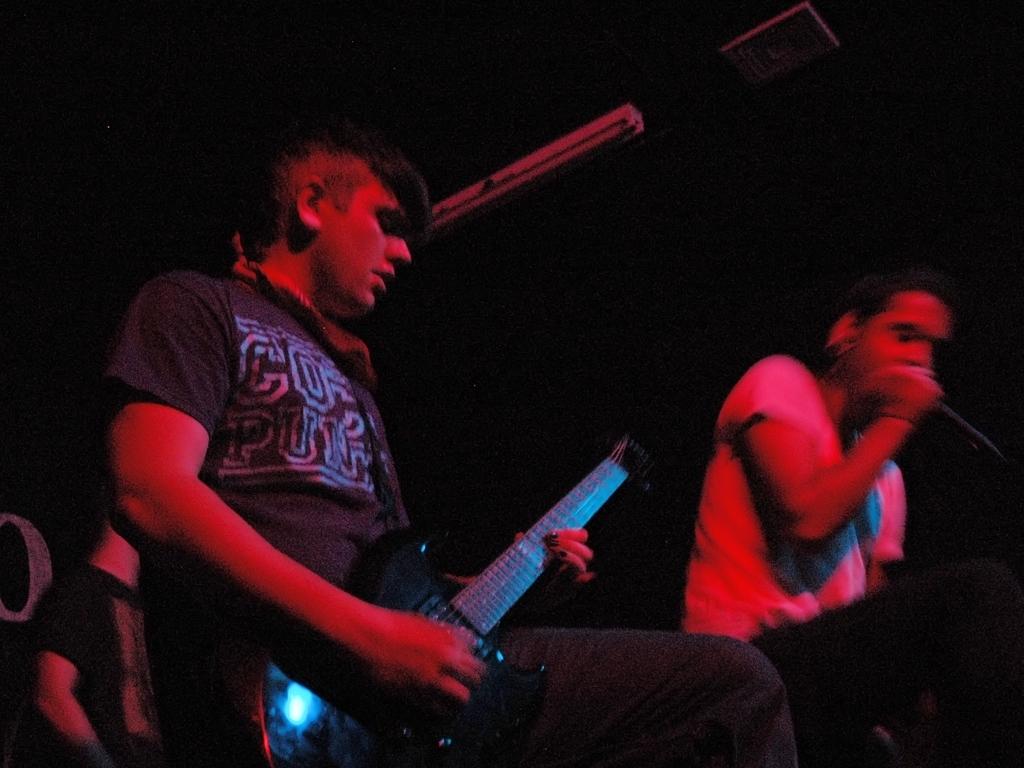What is the overall quality of this image? The overall quality of the image can be considered as poor due to several factors. The image appears to be underexposed and lacks sharpness, presumably because of low lighting conditions. Graininess is also evident, presumably due to a high ISO setting used during capture. The subjects' faces are not clearly visible, and the background is indistinct, hindering the image's ability to convey a clear narrative or visual appeal. 